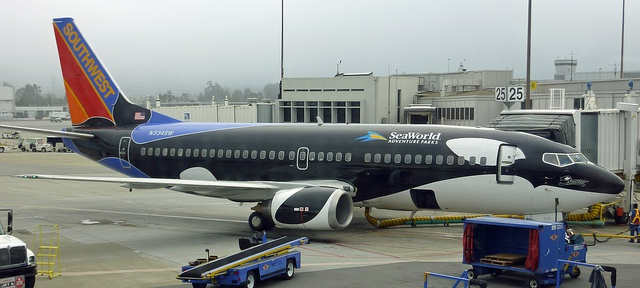Describe the objects in this image and their specific colors. I can see airplane in white, black, gray, darkgray, and lightgray tones, truck in white, black, navy, maroon, and darkblue tones, truck in white, black, navy, blue, and gray tones, truck in white, black, ivory, gray, and darkgray tones, and people in white, black, navy, gray, and maroon tones in this image. 